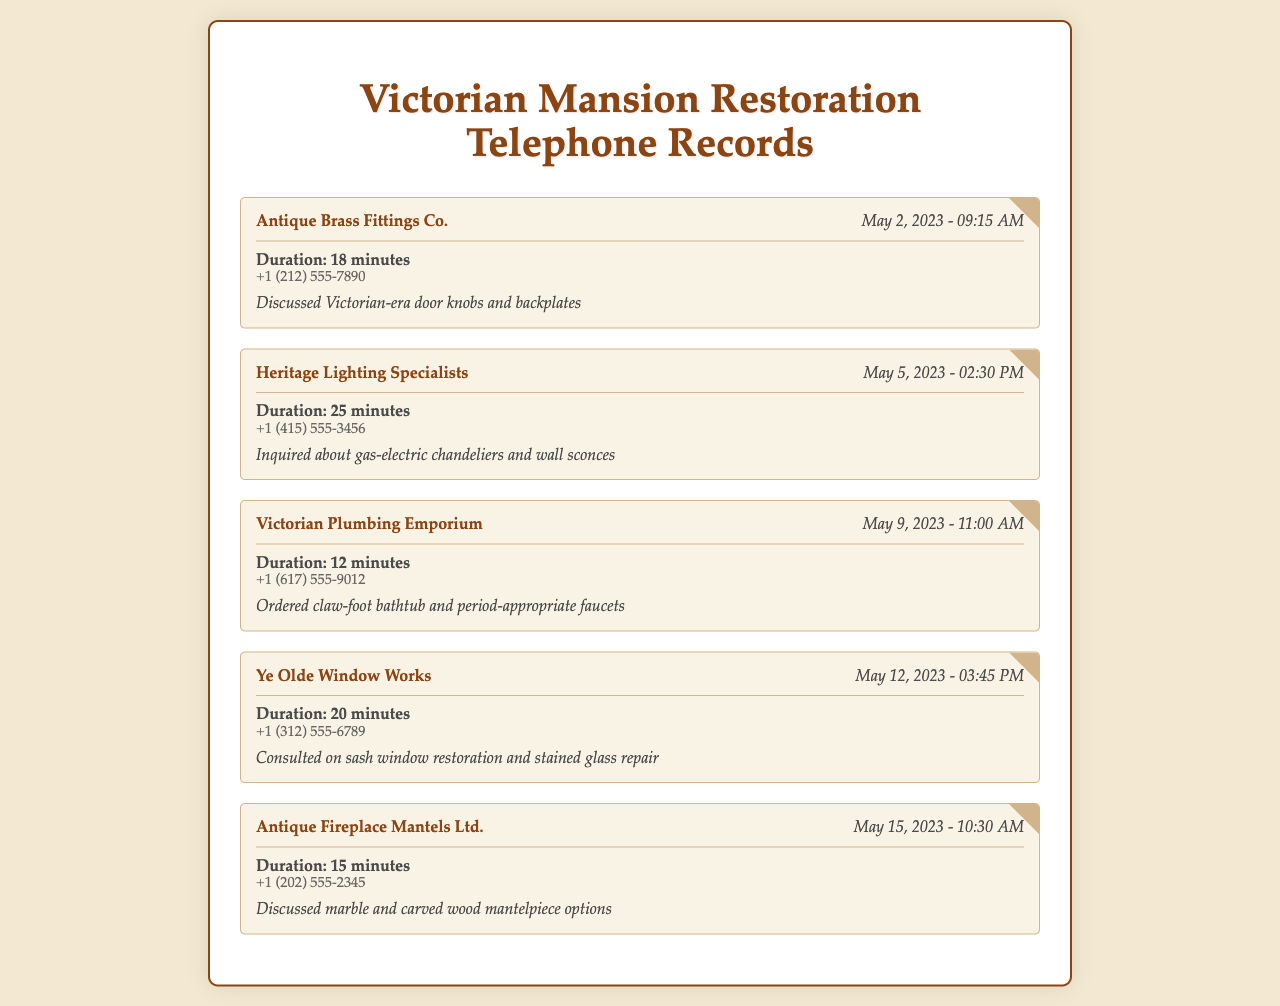What company was consulted on door knobs? The document lists "Antique Brass Fittings Co." as the company consulted regarding door knobs and backplates.
Answer: Antique Brass Fittings Co When did the call to Heritage Lighting Specialists occur? The date and time of the call to Heritage Lighting Specialists is mentioned in the document as May 5, 2023, at 02:30 PM.
Answer: May 5, 2023 - 02:30 PM What was ordered from Victorian Plumbing Emporium? The document indicates that a claw-foot bathtub and period-appropriate faucets were ordered from Victorian Plumbing Emporium.
Answer: Claw-foot bathtub and period-appropriate faucets How long was the consultation with Ye Olde Window Works? The duration of the consultation with Ye Olde Window Works is specified as 20 minutes in the document.
Answer: 20 minutes Which company specializes in stained glass repair? Ye Olde Window Works is noted for consulting on stained glass repair in the document.
Answer: Ye Olde Window Works What type of fixtures were discussed in the call to Antique Fireplace Mantels Ltd.? The document mentions the discussion centered around marble and carved wood mantelpiece options during the call.
Answer: Marble and carved wood mantelpiece options What was the phone number of Heritage Lighting Specialists? The document provides the phone number for Heritage Lighting Specialists as +1 (415) 555-3456.
Answer: +1 (415) 555-3456 Which company was consulted last according to the records? The last consultation listed in the document is with Antique Fireplace Mantels Ltd., dated May 15, 2023.
Answer: Antique Fireplace Mantels Ltd 